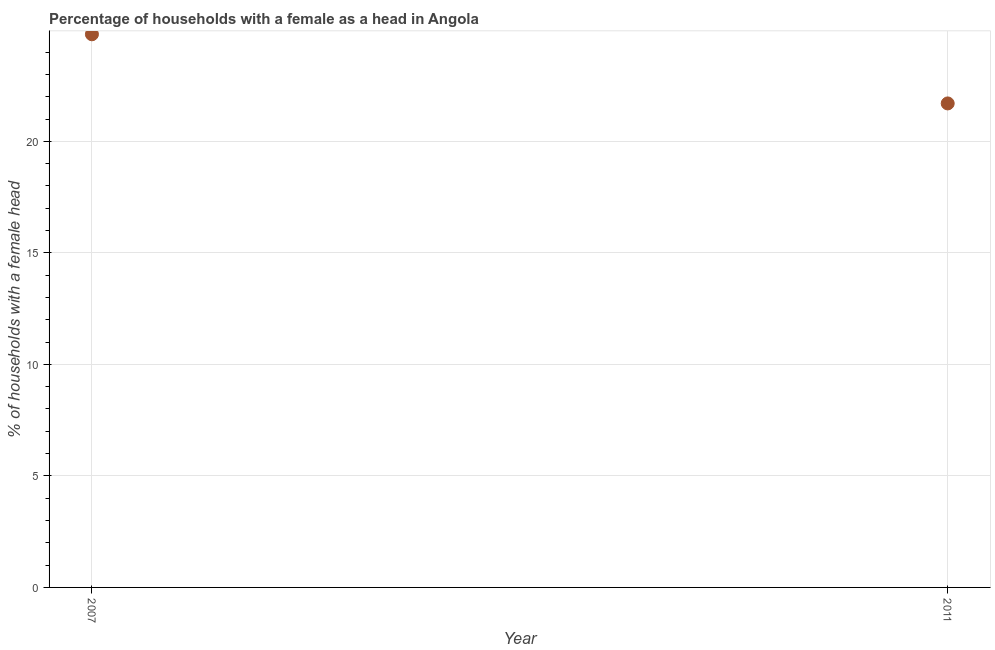What is the number of female supervised households in 2007?
Make the answer very short. 24.8. Across all years, what is the maximum number of female supervised households?
Provide a succinct answer. 24.8. Across all years, what is the minimum number of female supervised households?
Ensure brevity in your answer.  21.7. In which year was the number of female supervised households minimum?
Offer a very short reply. 2011. What is the sum of the number of female supervised households?
Make the answer very short. 46.5. What is the difference between the number of female supervised households in 2007 and 2011?
Make the answer very short. 3.1. What is the average number of female supervised households per year?
Offer a very short reply. 23.25. What is the median number of female supervised households?
Offer a terse response. 23.25. Do a majority of the years between 2007 and 2011 (inclusive) have number of female supervised households greater than 2 %?
Offer a very short reply. Yes. What is the ratio of the number of female supervised households in 2007 to that in 2011?
Ensure brevity in your answer.  1.14. Is the number of female supervised households in 2007 less than that in 2011?
Give a very brief answer. No. In how many years, is the number of female supervised households greater than the average number of female supervised households taken over all years?
Offer a terse response. 1. Does the number of female supervised households monotonically increase over the years?
Your response must be concise. No. How many dotlines are there?
Your answer should be compact. 1. How many years are there in the graph?
Provide a short and direct response. 2. What is the difference between two consecutive major ticks on the Y-axis?
Provide a short and direct response. 5. What is the title of the graph?
Your answer should be very brief. Percentage of households with a female as a head in Angola. What is the label or title of the Y-axis?
Ensure brevity in your answer.  % of households with a female head. What is the % of households with a female head in 2007?
Offer a very short reply. 24.8. What is the % of households with a female head in 2011?
Provide a short and direct response. 21.7. What is the difference between the % of households with a female head in 2007 and 2011?
Your answer should be compact. 3.1. What is the ratio of the % of households with a female head in 2007 to that in 2011?
Your response must be concise. 1.14. 